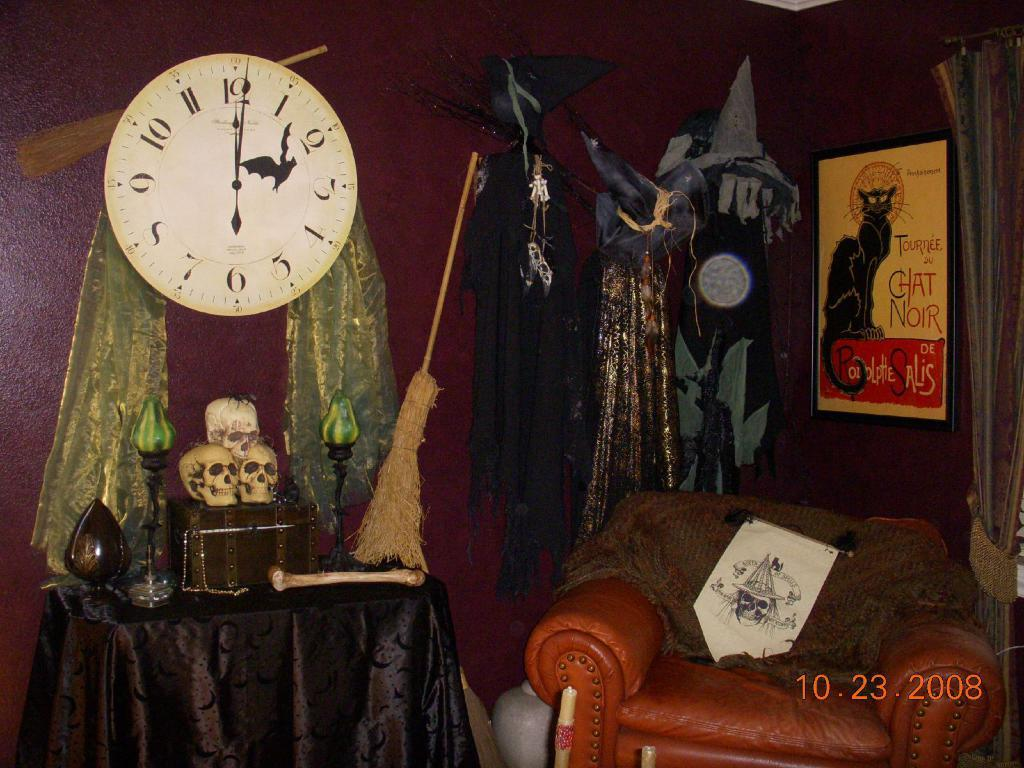<image>
Give a short and clear explanation of the subsequent image. A picture of several Halloween props including a broom, skulls and candles taken on October 23, 2008 